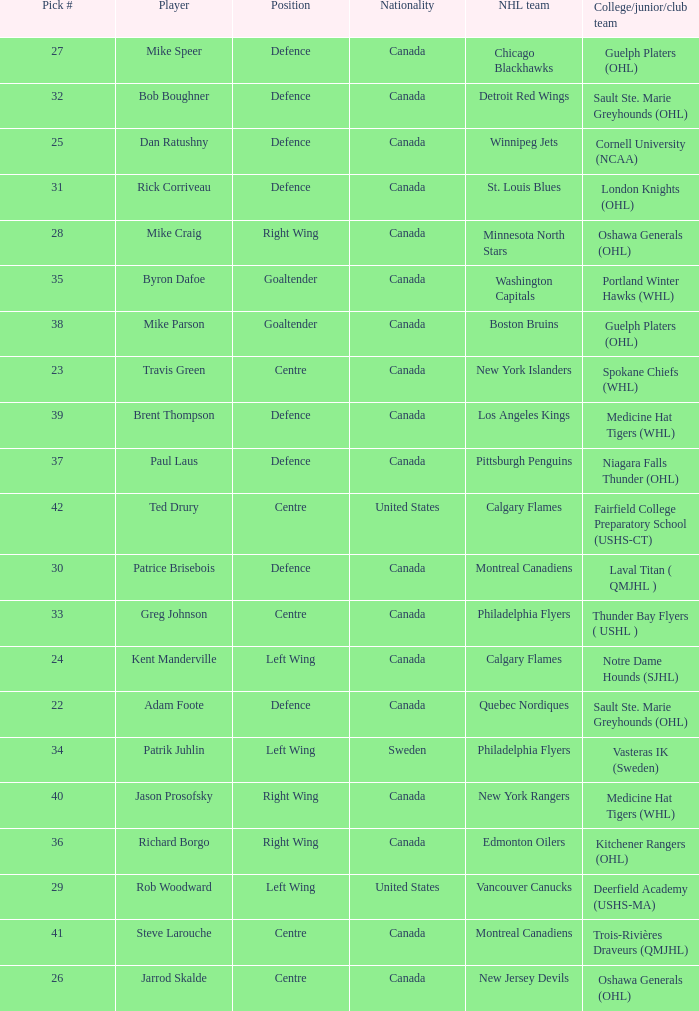What NHL team picked richard borgo? Edmonton Oilers. Parse the full table. {'header': ['Pick #', 'Player', 'Position', 'Nationality', 'NHL team', 'College/junior/club team'], 'rows': [['27', 'Mike Speer', 'Defence', 'Canada', 'Chicago Blackhawks', 'Guelph Platers (OHL)'], ['32', 'Bob Boughner', 'Defence', 'Canada', 'Detroit Red Wings', 'Sault Ste. Marie Greyhounds (OHL)'], ['25', 'Dan Ratushny', 'Defence', 'Canada', 'Winnipeg Jets', 'Cornell University (NCAA)'], ['31', 'Rick Corriveau', 'Defence', 'Canada', 'St. Louis Blues', 'London Knights (OHL)'], ['28', 'Mike Craig', 'Right Wing', 'Canada', 'Minnesota North Stars', 'Oshawa Generals (OHL)'], ['35', 'Byron Dafoe', 'Goaltender', 'Canada', 'Washington Capitals', 'Portland Winter Hawks (WHL)'], ['38', 'Mike Parson', 'Goaltender', 'Canada', 'Boston Bruins', 'Guelph Platers (OHL)'], ['23', 'Travis Green', 'Centre', 'Canada', 'New York Islanders', 'Spokane Chiefs (WHL)'], ['39', 'Brent Thompson', 'Defence', 'Canada', 'Los Angeles Kings', 'Medicine Hat Tigers (WHL)'], ['37', 'Paul Laus', 'Defence', 'Canada', 'Pittsburgh Penguins', 'Niagara Falls Thunder (OHL)'], ['42', 'Ted Drury', 'Centre', 'United States', 'Calgary Flames', 'Fairfield College Preparatory School (USHS-CT)'], ['30', 'Patrice Brisebois', 'Defence', 'Canada', 'Montreal Canadiens', 'Laval Titan ( QMJHL )'], ['33', 'Greg Johnson', 'Centre', 'Canada', 'Philadelphia Flyers', 'Thunder Bay Flyers ( USHL )'], ['24', 'Kent Manderville', 'Left Wing', 'Canada', 'Calgary Flames', 'Notre Dame Hounds (SJHL)'], ['22', 'Adam Foote', 'Defence', 'Canada', 'Quebec Nordiques', 'Sault Ste. Marie Greyhounds (OHL)'], ['34', 'Patrik Juhlin', 'Left Wing', 'Sweden', 'Philadelphia Flyers', 'Vasteras IK (Sweden)'], ['40', 'Jason Prosofsky', 'Right Wing', 'Canada', 'New York Rangers', 'Medicine Hat Tigers (WHL)'], ['36', 'Richard Borgo', 'Right Wing', 'Canada', 'Edmonton Oilers', 'Kitchener Rangers (OHL)'], ['29', 'Rob Woodward', 'Left Wing', 'United States', 'Vancouver Canucks', 'Deerfield Academy (USHS-MA)'], ['41', 'Steve Larouche', 'Centre', 'Canada', 'Montreal Canadiens', 'Trois-Rivières Draveurs (QMJHL)'], ['26', 'Jarrod Skalde', 'Centre', 'Canada', 'New Jersey Devils', 'Oshawa Generals (OHL)']]} 